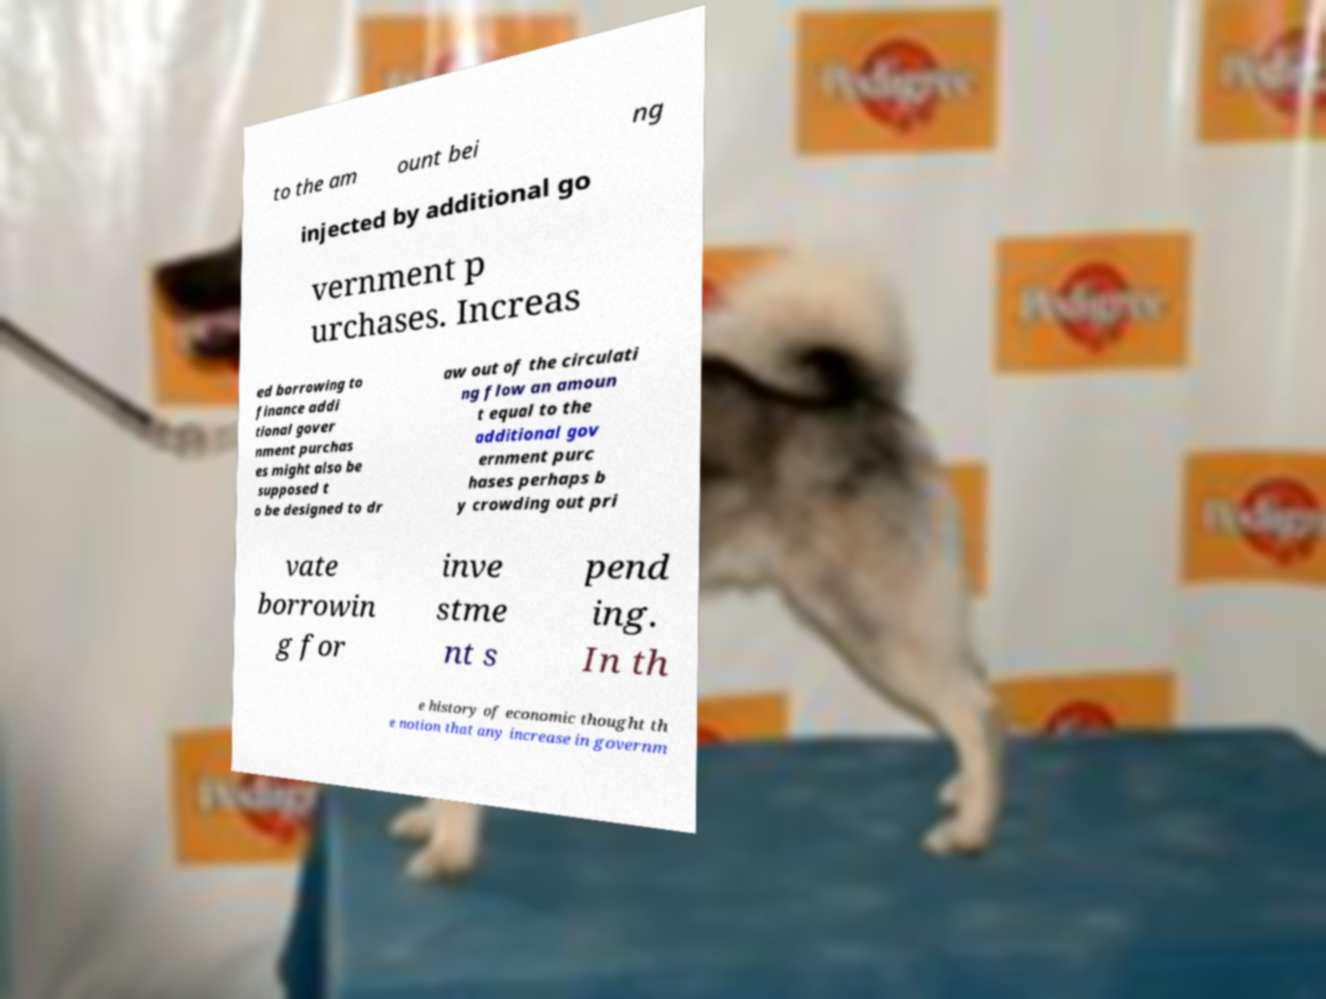Could you assist in decoding the text presented in this image and type it out clearly? to the am ount bei ng injected by additional go vernment p urchases. Increas ed borrowing to finance addi tional gover nment purchas es might also be supposed t o be designed to dr aw out of the circulati ng flow an amoun t equal to the additional gov ernment purc hases perhaps b y crowding out pri vate borrowin g for inve stme nt s pend ing. In th e history of economic thought th e notion that any increase in governm 